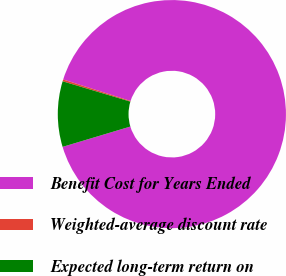<chart> <loc_0><loc_0><loc_500><loc_500><pie_chart><fcel>Benefit Cost for Years Ended<fcel>Weighted-average discount rate<fcel>Expected long-term return on<nl><fcel>90.46%<fcel>0.26%<fcel>9.28%<nl></chart> 